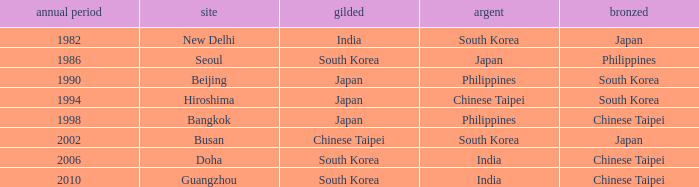Which Bronze has a Year smaller than 1994, and a Silver of south korea? Japan. 